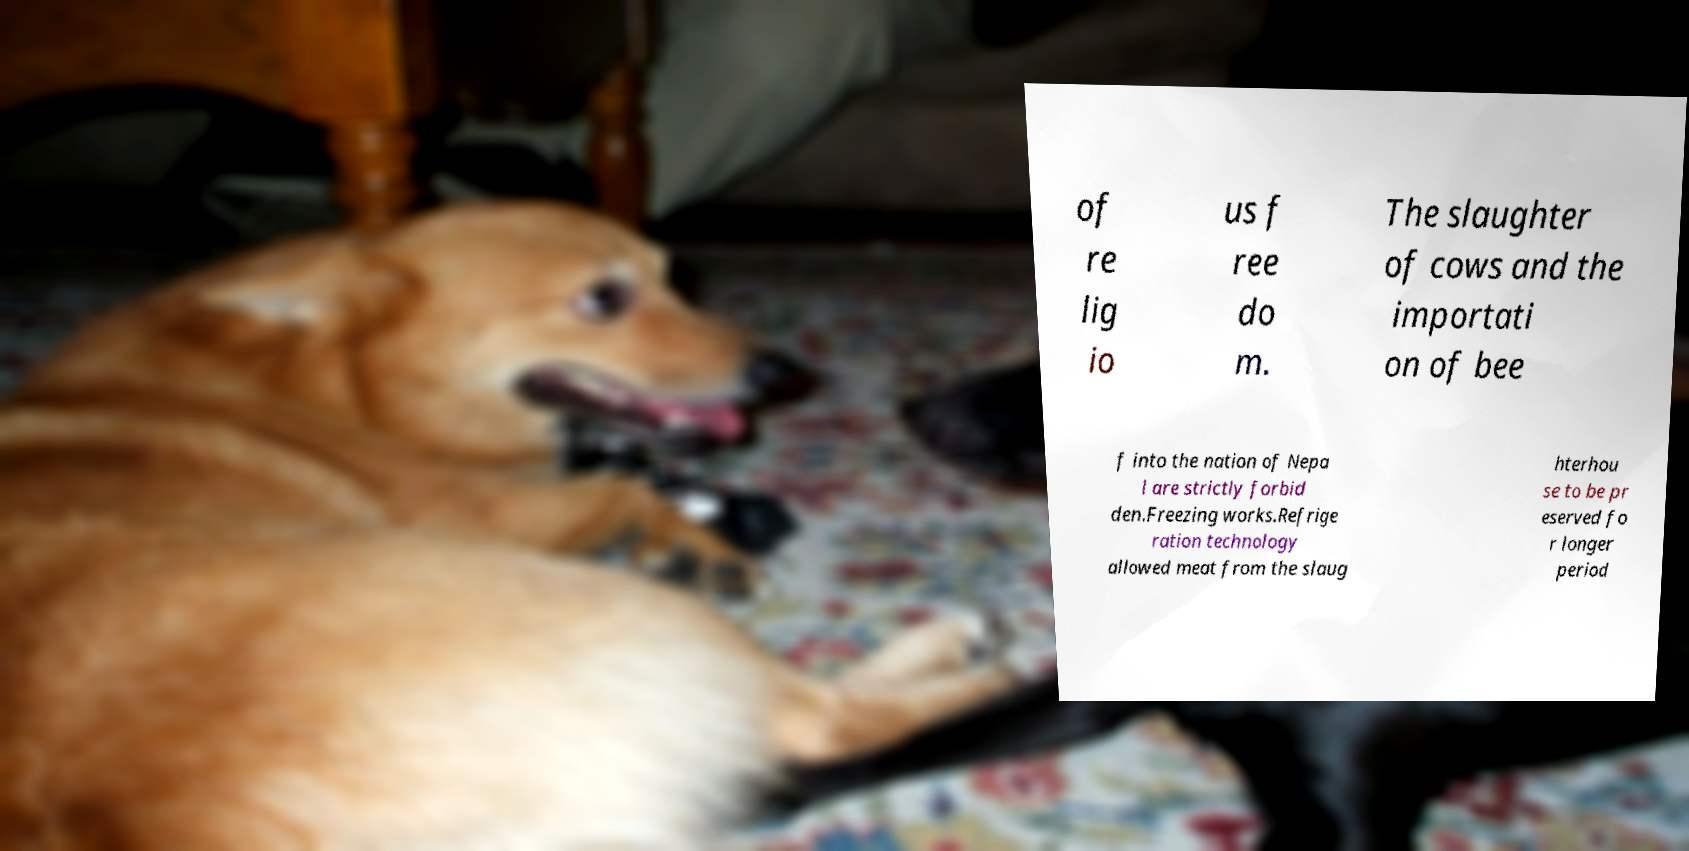I need the written content from this picture converted into text. Can you do that? of re lig io us f ree do m. The slaughter of cows and the importati on of bee f into the nation of Nepa l are strictly forbid den.Freezing works.Refrige ration technology allowed meat from the slaug hterhou se to be pr eserved fo r longer period 